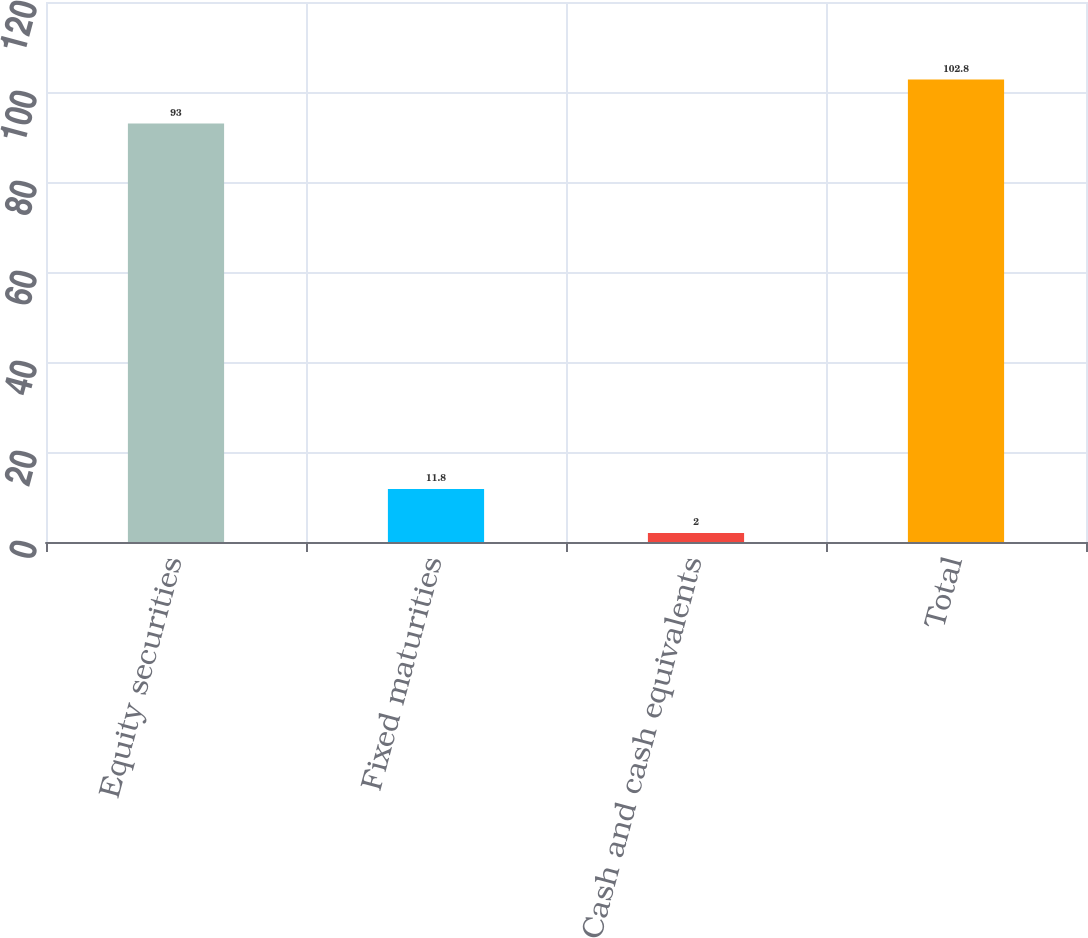<chart> <loc_0><loc_0><loc_500><loc_500><bar_chart><fcel>Equity securities<fcel>Fixed maturities<fcel>Cash and cash equivalents<fcel>Total<nl><fcel>93<fcel>11.8<fcel>2<fcel>102.8<nl></chart> 